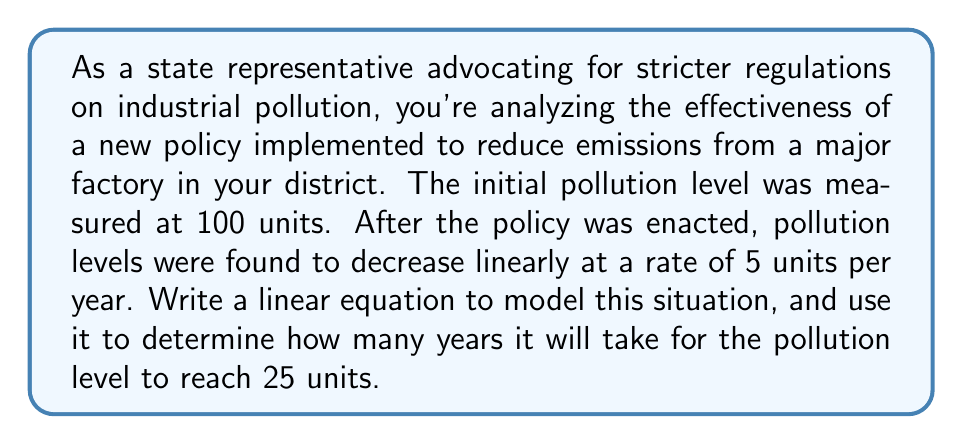Could you help me with this problem? Let's approach this step-by-step:

1) First, we need to identify the variables:
   Let $y$ represent the pollution level in units
   Let $x$ represent the time in years since the policy was implemented

2) We know that the initial pollution level (when $x = 0$) was 100 units. This gives us our y-intercept.

3) The pollution is decreasing at a rate of 5 units per year. Since it's decreasing, our slope will be negative: -5.

4) Now we can write our linear equation in slope-intercept form:
   $$ y = mx + b $$
   Where $m$ is the slope and $b$ is the y-intercept.

5) Plugging in our values:
   $$ y = -5x + 100 $$

6) To find how long it will take to reach 25 units, we set $y = 25$ and solve for $x$:
   $$ 25 = -5x + 100 $$

7) Subtracting 100 from both sides:
   $$ -75 = -5x $$

8) Dividing both sides by -5:
   $$ 15 = x $$

Therefore, it will take 15 years for the pollution level to reach 25 units.
Answer: 15 years 